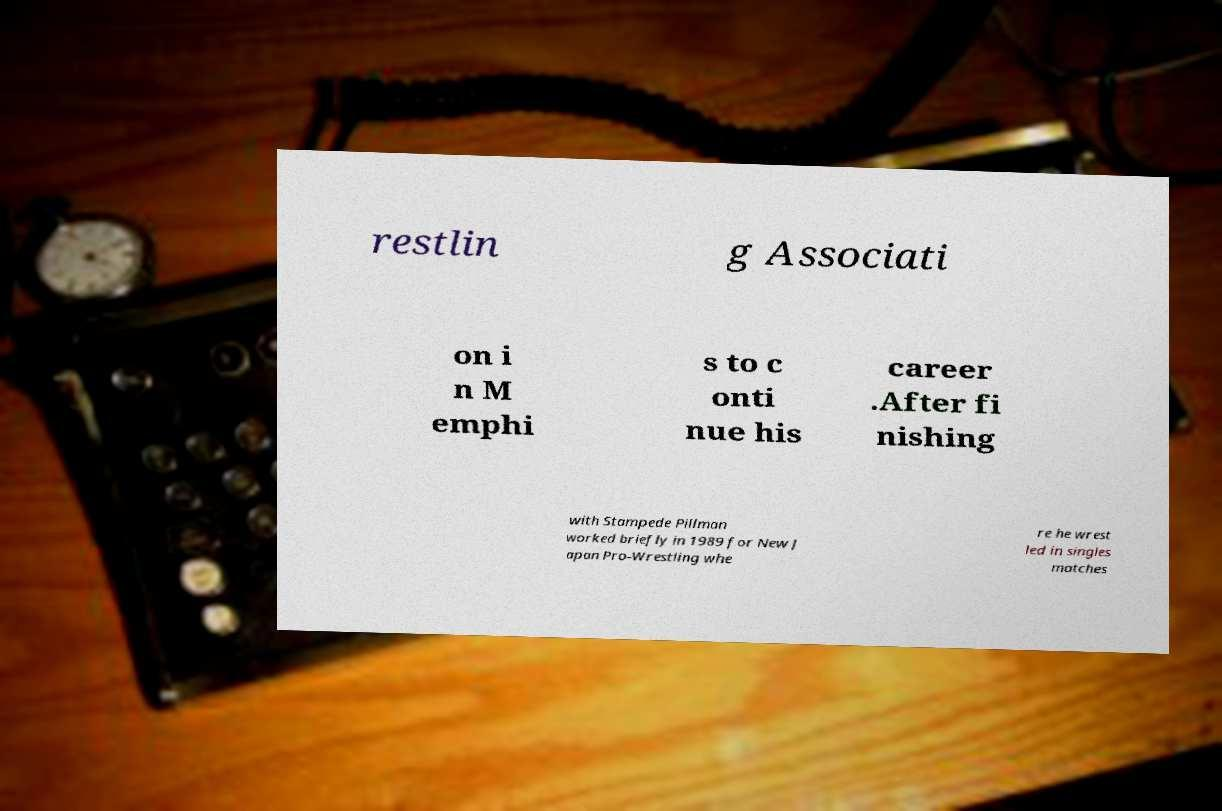Could you extract and type out the text from this image? restlin g Associati on i n M emphi s to c onti nue his career .After fi nishing with Stampede Pillman worked briefly in 1989 for New J apan Pro-Wrestling whe re he wrest led in singles matches 